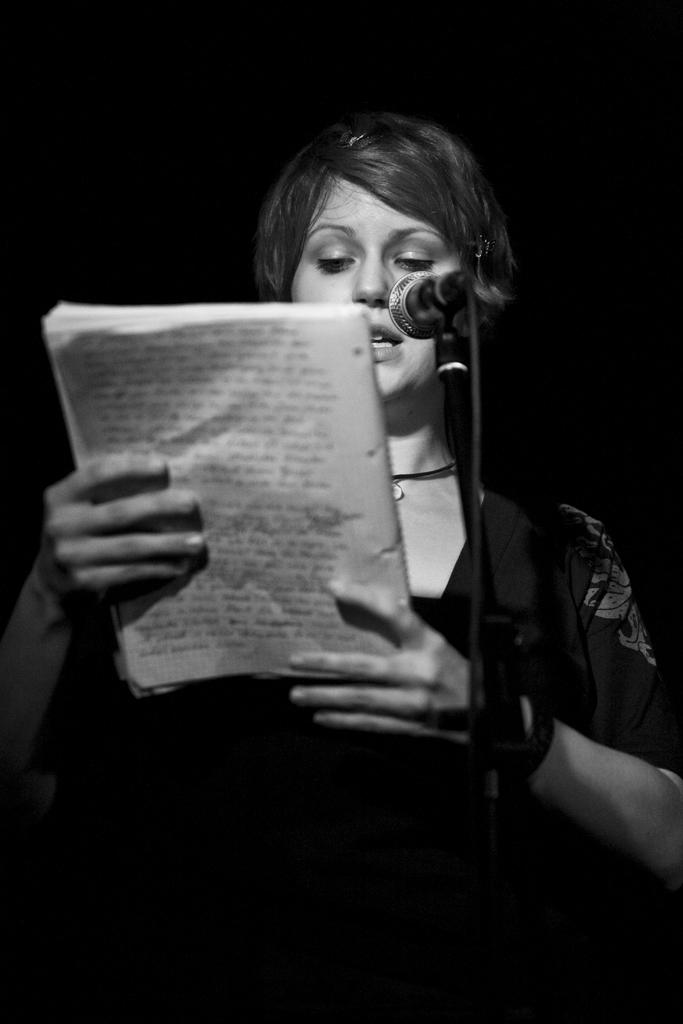What is the color scheme of the image? The image is black and white. Can you describe the person in the image? There is a lady in the image. What is the lady holding in the image? The lady is holding a book. What other object can be seen in the image? There is a microphone (mic) in the image. How many boys are present in the image? There are no boys present in the image; it features a lady holding a book and a microphone. Can you tell me what the visitor is doing in the image? There is no visitor present in the image. 